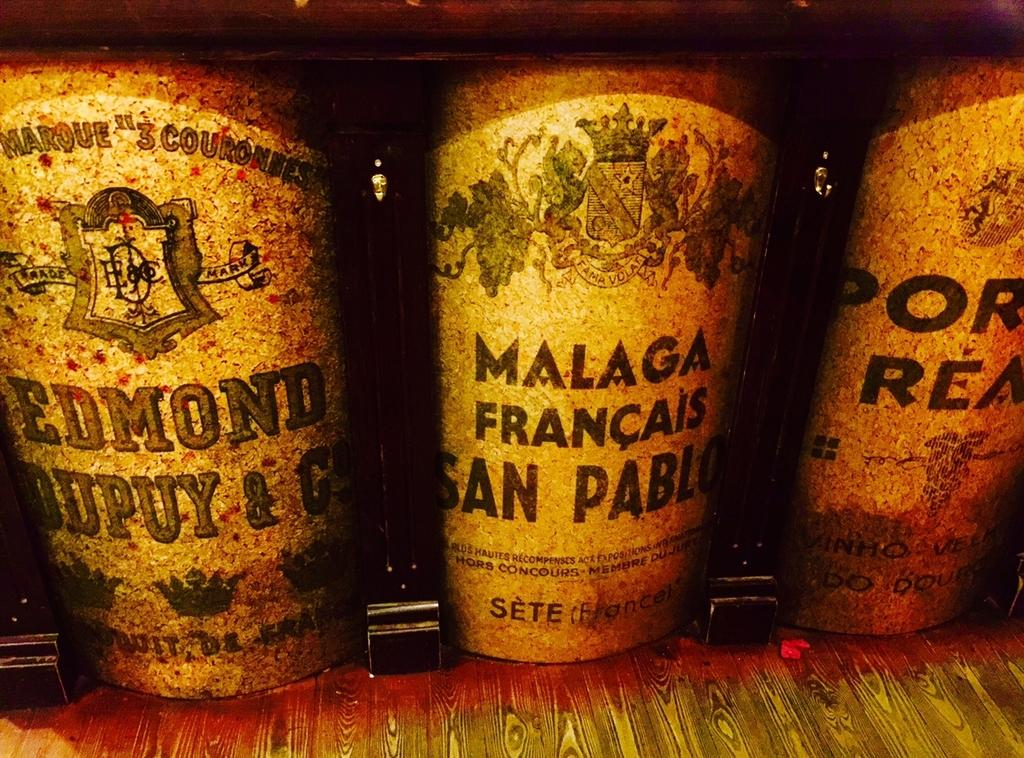<image>
Write a terse but informative summary of the picture. Three containers on a shelf with French labels on them. 